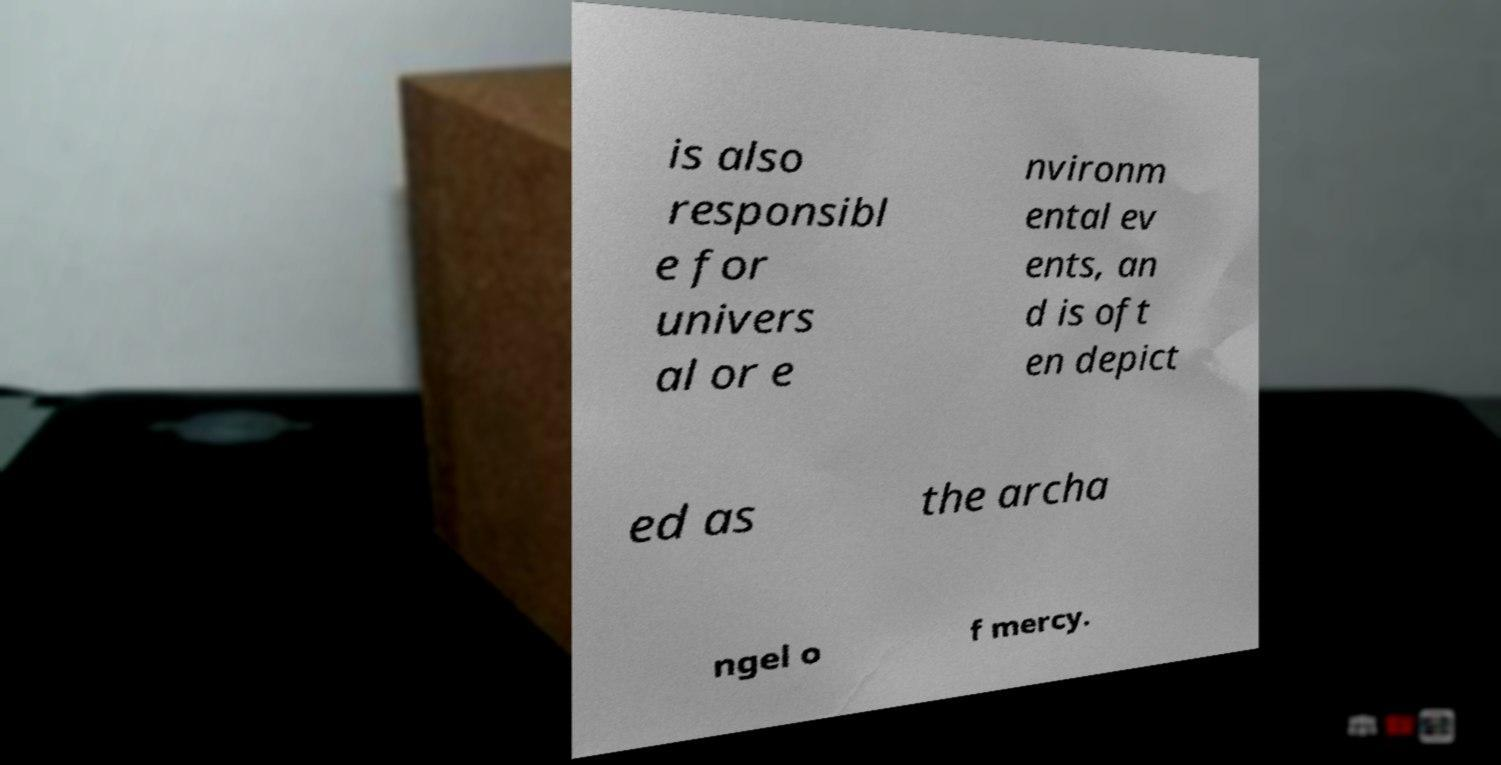Can you accurately transcribe the text from the provided image for me? is also responsibl e for univers al or e nvironm ental ev ents, an d is oft en depict ed as the archa ngel o f mercy. 